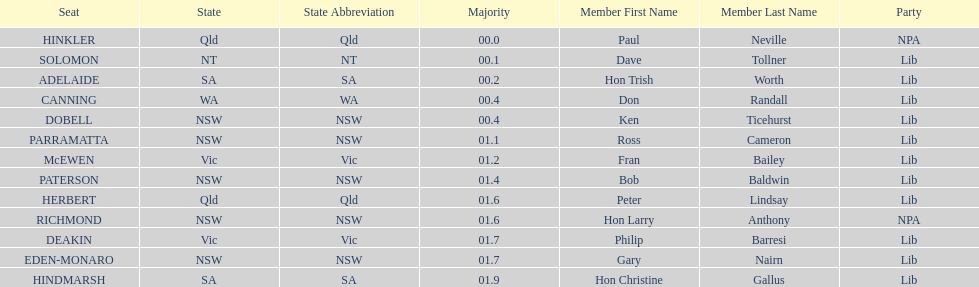Was fran bailey from vic or wa? Vic. Could you parse the entire table as a dict? {'header': ['Seat', 'State', 'State Abbreviation', 'Majority', 'Member First Name', 'Member Last Name', 'Party'], 'rows': [['HINKLER', 'Qld', 'Qld', '00.0', 'Paul', 'Neville', 'NPA'], ['SOLOMON', 'NT', 'NT', '00.1', 'Dave', 'Tollner', 'Lib'], ['ADELAIDE', 'SA', 'SA', '00.2', 'Hon Trish', 'Worth', 'Lib'], ['CANNING', 'WA', 'WA', '00.4', 'Don', 'Randall', 'Lib'], ['DOBELL', 'NSW', 'NSW', '00.4', 'Ken', 'Ticehurst', 'Lib'], ['PARRAMATTA', 'NSW', 'NSW', '01.1', 'Ross', 'Cameron', 'Lib'], ['McEWEN', 'Vic', 'Vic', '01.2', 'Fran', 'Bailey', 'Lib'], ['PATERSON', 'NSW', 'NSW', '01.4', 'Bob', 'Baldwin', 'Lib'], ['HERBERT', 'Qld', 'Qld', '01.6', 'Peter', 'Lindsay', 'Lib'], ['RICHMOND', 'NSW', 'NSW', '01.6', 'Hon Larry', 'Anthony', 'NPA'], ['DEAKIN', 'Vic', 'Vic', '01.7', 'Philip', 'Barresi', 'Lib'], ['EDEN-MONARO', 'NSW', 'NSW', '01.7', 'Gary', 'Nairn', 'Lib'], ['HINDMARSH', 'SA', 'SA', '01.9', 'Hon Christine', 'Gallus', 'Lib']]} 